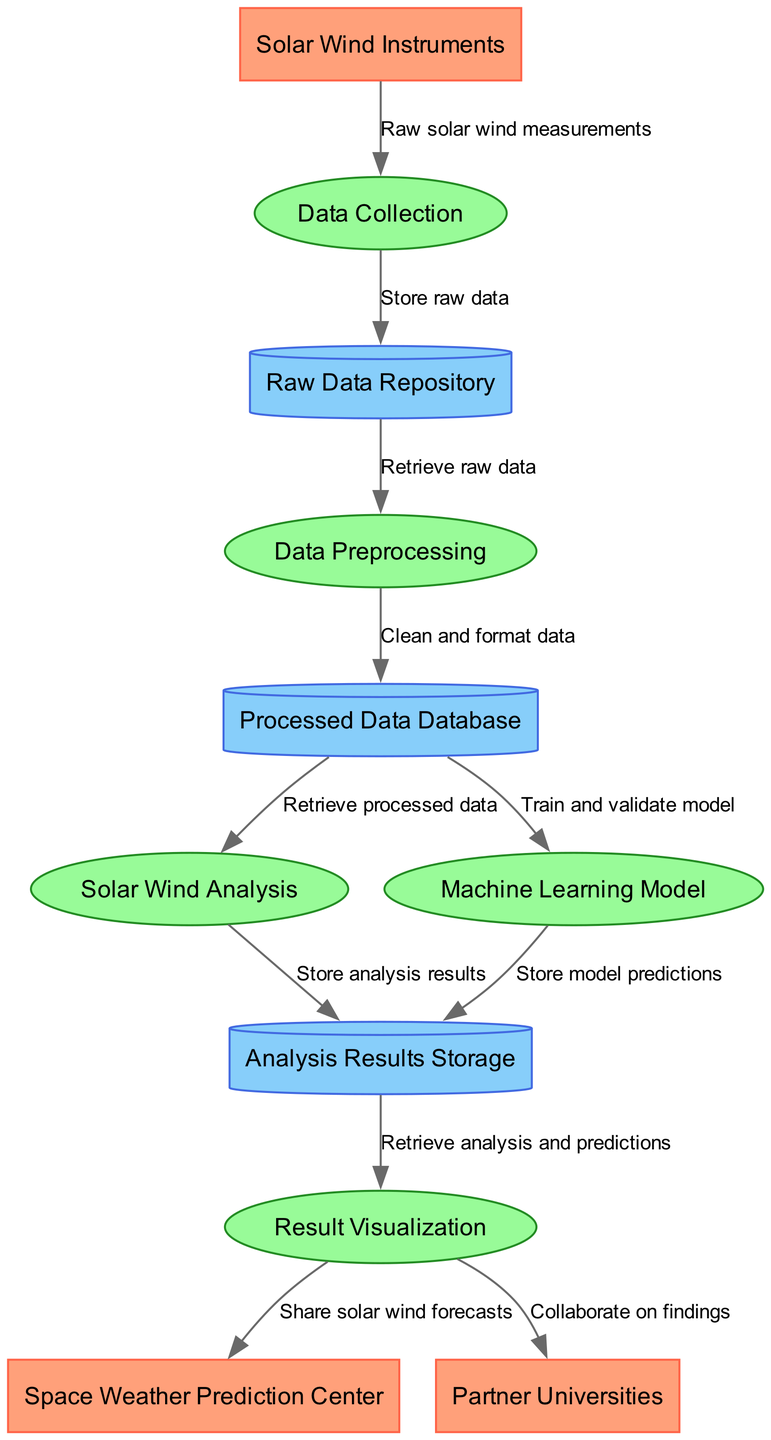What are the external entities involved in the diagram? The diagram lists three external entities: Solar Wind Instruments, Space Weather Prediction Center, and Partner Universities. These can be identified as the initial elements connected to the processes in the data flow.
Answer: Solar Wind Instruments, Space Weather Prediction Center, Partner Universities What is the first process in the data flow? The first process that appears in the diagram is "Data Collection". Looking at the flow of the diagram, it is the first process connected to the external entity "Solar Wind Instruments".
Answer: Data Collection How many data stores are presented in the diagram? The diagram contains three data stores: Raw Data Repository, Processed Data Database, and Analysis Results Storage. Each store is represented as a distinct cylinder shape in the visual representation.
Answer: 3 What type of data flows from Data Preprocessing to Processed Data Database? The data flow from Data Preprocessing to the Processed Data Database is labeled "Clean and format data", indicating the specific action taken as data transitions from one element to the other.
Answer: Clean and format data What is the last process in the data flow? The last process in the data flow is "Result Visualization". It is the process that comes after the analysis results have been stored, leading to the sharing of findings with external entities.
Answer: Result Visualization How does the Machine Learning Model contribute to the data flow? The Machine Learning Model takes processed data from the Processed Data Database to train and validate models, thus directly impacting the analysis results stored in the Analysis Results Storage, showcasing its role in advancing the research findings.
Answer: Store model predictions Which external entity receives solar wind forecasts? The external entity that receives solar wind forecasts as indicated by the diagram is the Space Weather Prediction Center. This relationship is established through the flow labeled "Share solar wind forecasts" emanating from Result Visualization.
Answer: Space Weather Prediction Center Which process receives raw solar wind measurements? The process that receives raw solar wind measurements is the "Data Collection". This is illustrated as the initial step in the diagram where the flow from "Solar Wind Instruments" leads directly to it.
Answer: Data Collection What is the total number of processes in the data flow? There are five processes in the data flow: Data Collection, Data Preprocessing, Solar Wind Analysis, Machine Learning Model, and Result Visualization. Counting each of these processes confirms the total.
Answer: 5 